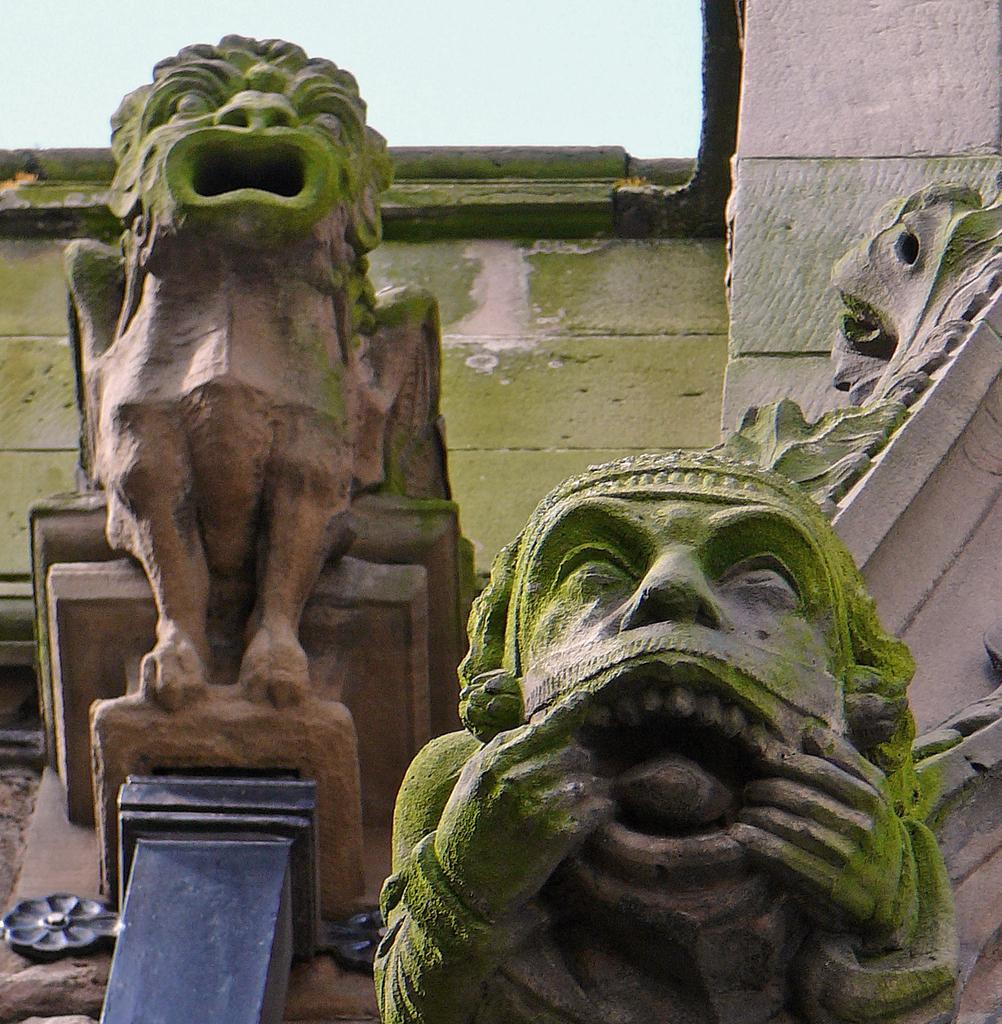What is the main subject of the image? There is a sculpture in the image. What type of trip can be seen in the image? There is no trip present in the image; it features a sculpture. What is the shape of the yoke in the image? There is no yoke present in the image; it features a sculpture. 